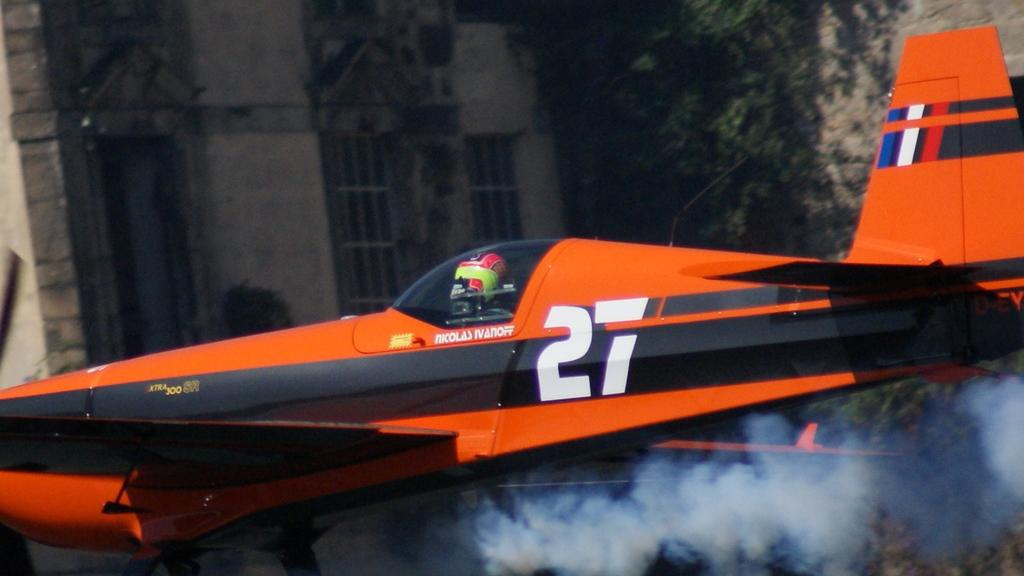<image>
Offer a succinct explanation of the picture presented. back of an airplane flown by Nicholas Ivanoff that is # 27. 